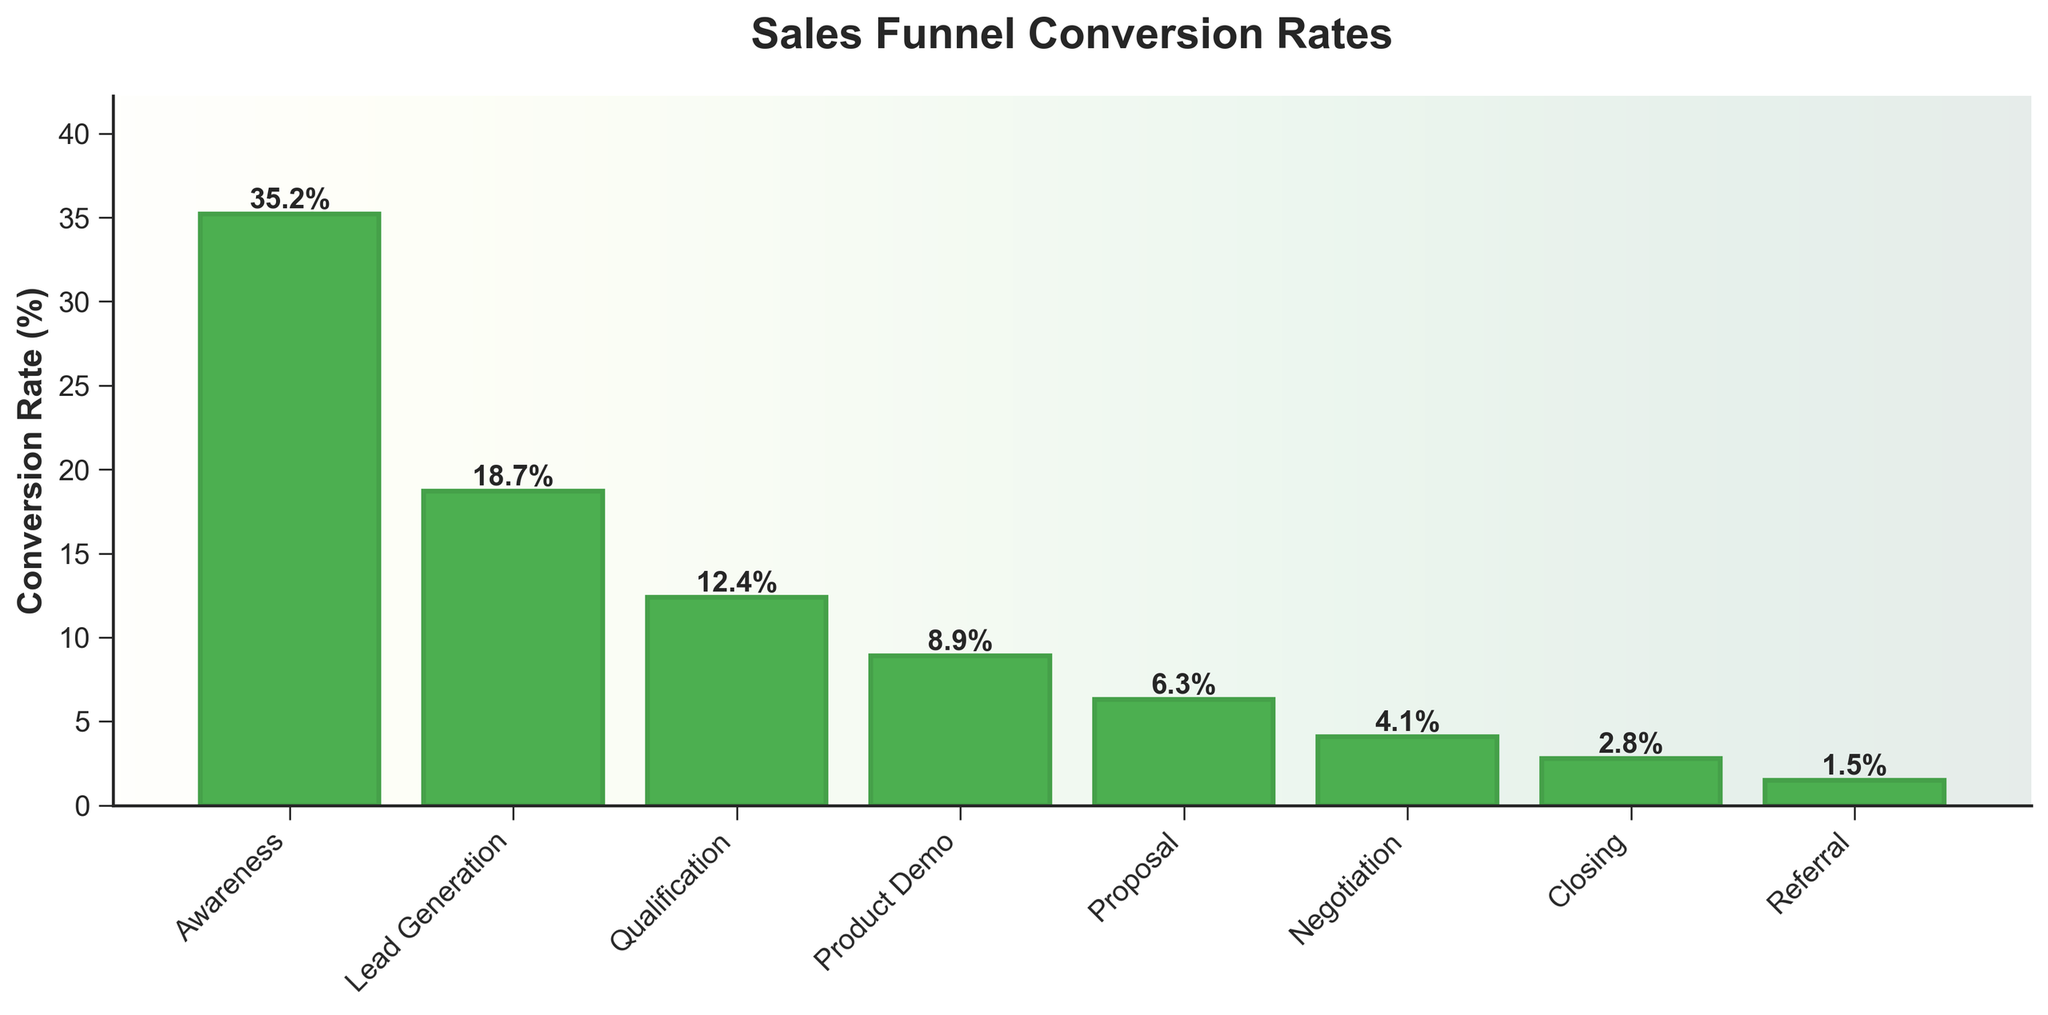What's the conversion rate at the Product Demo stage? To find the conversion rate at the Product Demo stage, locate the corresponding bar labeled "Product Demo," and refer to the height of that bar or the text above it.
Answer: 8.9% Which stage has a lower conversion rate, Qualification or Proposal? Compare the heights of the bars labeled "Qualification" and "Proposal." The Proposal bar is lower (6.3%) than the Qualification bar (12.4%).
Answer: Proposal What is the difference in conversion rates between the Awareness and Closing stages? Subtract the conversion rate of the Closing stage (2.8%) from the conversion rate of the Awareness stage (35.2%). 35.2% - 2.8% = 32.4%
Answer: 32.4% Are there more stages above a 10% conversion rate or below it? Count the number of bars above 10% conversion rate: Awareness, Lead Generation, Qualification (3 bars). Count the number below 10%: Product Demo, Proposal, Negotiation, Closing, Referral (5 bars).
Answer: Below Which stage has the highest conversion rate and what is that rate? Identify the tallest bar in the chart and check the text above it. The tallest bar is Awareness with a conversion rate of 35.2%.
Answer: Awareness, 35.2% What is the average conversion rate across all stages? Sum the conversion rates and divide by the number of stages: (35.2 + 18.7 + 12.4 + 8.9 + 6.3 + 4.1 + 2.8 + 1.5) = 89.9. 89.9 / 8 = 11.2%
Answer: 11.2% How many stages have a conversion rate less than 5%? Count the bars with heights below 5%: Negotiation, Closing, Referral (3 bars).
Answer: 3 What is the sum of the conversion rates for the Lead Generation and Proposal stages? Add the conversion rates for Lead Generation (18.7%) and Proposal (6.3%). 18.7 + 6.3 = 25.0%
Answer: 25.0% Which stage has the smallest conversion rate and what is that rate? Identify the shortest bar in the chart and check the text above it. The shortest bar is Referral with a conversion rate of 1.5%.
Answer: Referral, 1.5% 